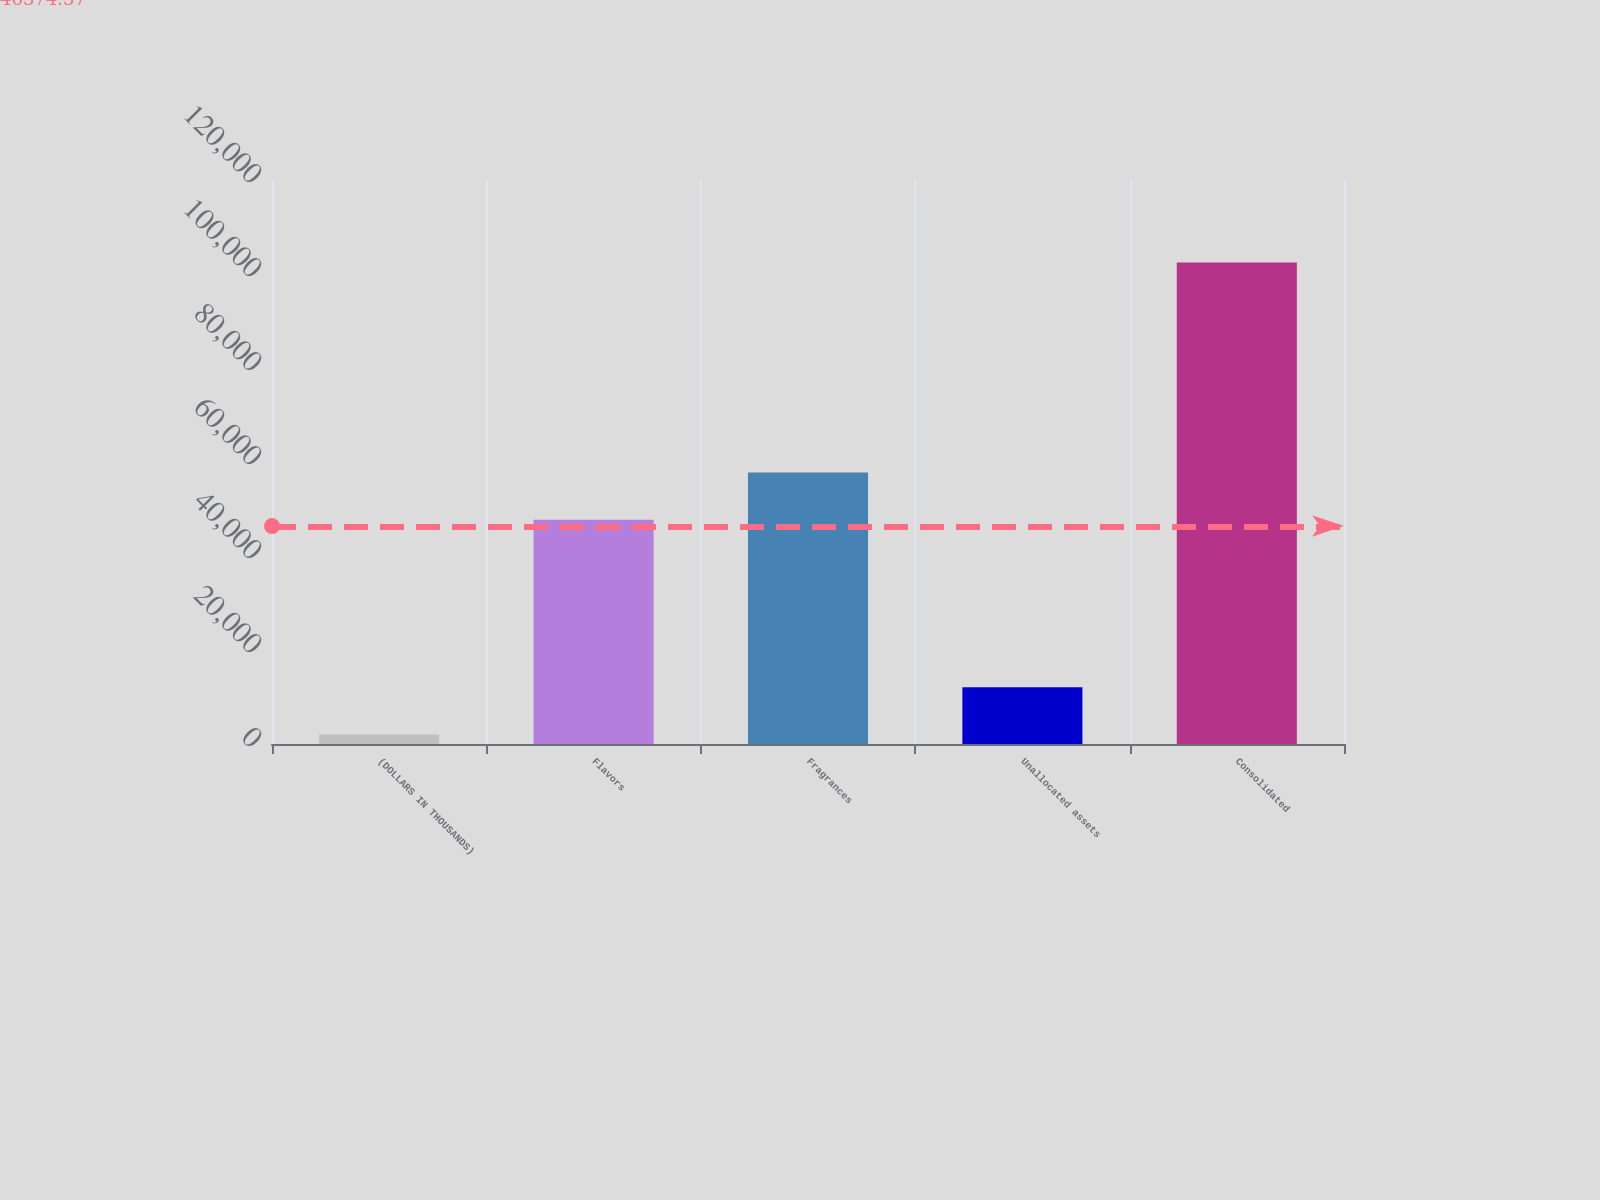Convert chart. <chart><loc_0><loc_0><loc_500><loc_500><bar_chart><fcel>(DOLLARS IN THOUSANDS)<fcel>Flavors<fcel>Fragrances<fcel>Unallocated assets<fcel>Consolidated<nl><fcel>2016<fcel>47705<fcel>57750.3<fcel>12061.3<fcel>102469<nl></chart> 